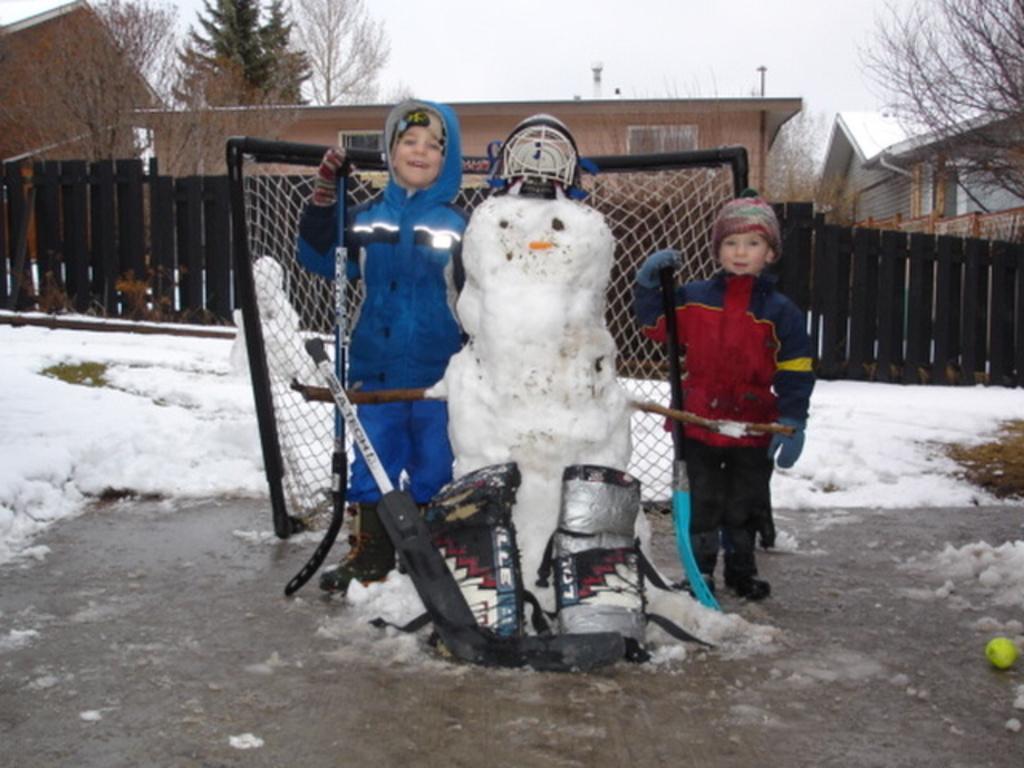Please provide a concise description of this image. Here we can see two children and this is an object made with snow. This is snow and there is a mesh. In the background we can see a fence, houses, trees, and sky. 